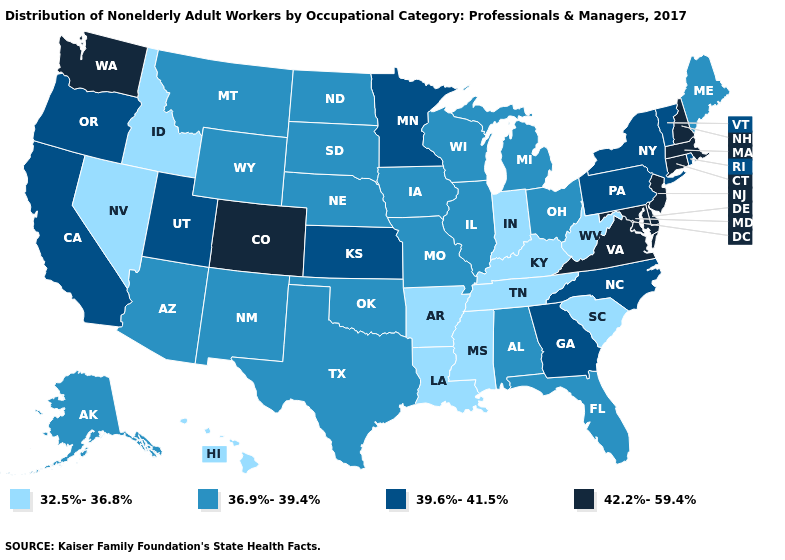Which states have the lowest value in the MidWest?
Write a very short answer. Indiana. Name the states that have a value in the range 36.9%-39.4%?
Answer briefly. Alabama, Alaska, Arizona, Florida, Illinois, Iowa, Maine, Michigan, Missouri, Montana, Nebraska, New Mexico, North Dakota, Ohio, Oklahoma, South Dakota, Texas, Wisconsin, Wyoming. Is the legend a continuous bar?
Be succinct. No. Does Idaho have the lowest value in the West?
Answer briefly. Yes. Among the states that border Georgia , which have the lowest value?
Quick response, please. South Carolina, Tennessee. How many symbols are there in the legend?
Quick response, please. 4. Name the states that have a value in the range 39.6%-41.5%?
Give a very brief answer. California, Georgia, Kansas, Minnesota, New York, North Carolina, Oregon, Pennsylvania, Rhode Island, Utah, Vermont. Which states hav the highest value in the South?
Be succinct. Delaware, Maryland, Virginia. Name the states that have a value in the range 36.9%-39.4%?
Quick response, please. Alabama, Alaska, Arizona, Florida, Illinois, Iowa, Maine, Michigan, Missouri, Montana, Nebraska, New Mexico, North Dakota, Ohio, Oklahoma, South Dakota, Texas, Wisconsin, Wyoming. What is the value of Florida?
Keep it brief. 36.9%-39.4%. What is the value of Massachusetts?
Give a very brief answer. 42.2%-59.4%. Name the states that have a value in the range 39.6%-41.5%?
Be succinct. California, Georgia, Kansas, Minnesota, New York, North Carolina, Oregon, Pennsylvania, Rhode Island, Utah, Vermont. Name the states that have a value in the range 42.2%-59.4%?
Keep it brief. Colorado, Connecticut, Delaware, Maryland, Massachusetts, New Hampshire, New Jersey, Virginia, Washington. What is the lowest value in states that border Wyoming?
Concise answer only. 32.5%-36.8%. Name the states that have a value in the range 39.6%-41.5%?
Be succinct. California, Georgia, Kansas, Minnesota, New York, North Carolina, Oregon, Pennsylvania, Rhode Island, Utah, Vermont. 